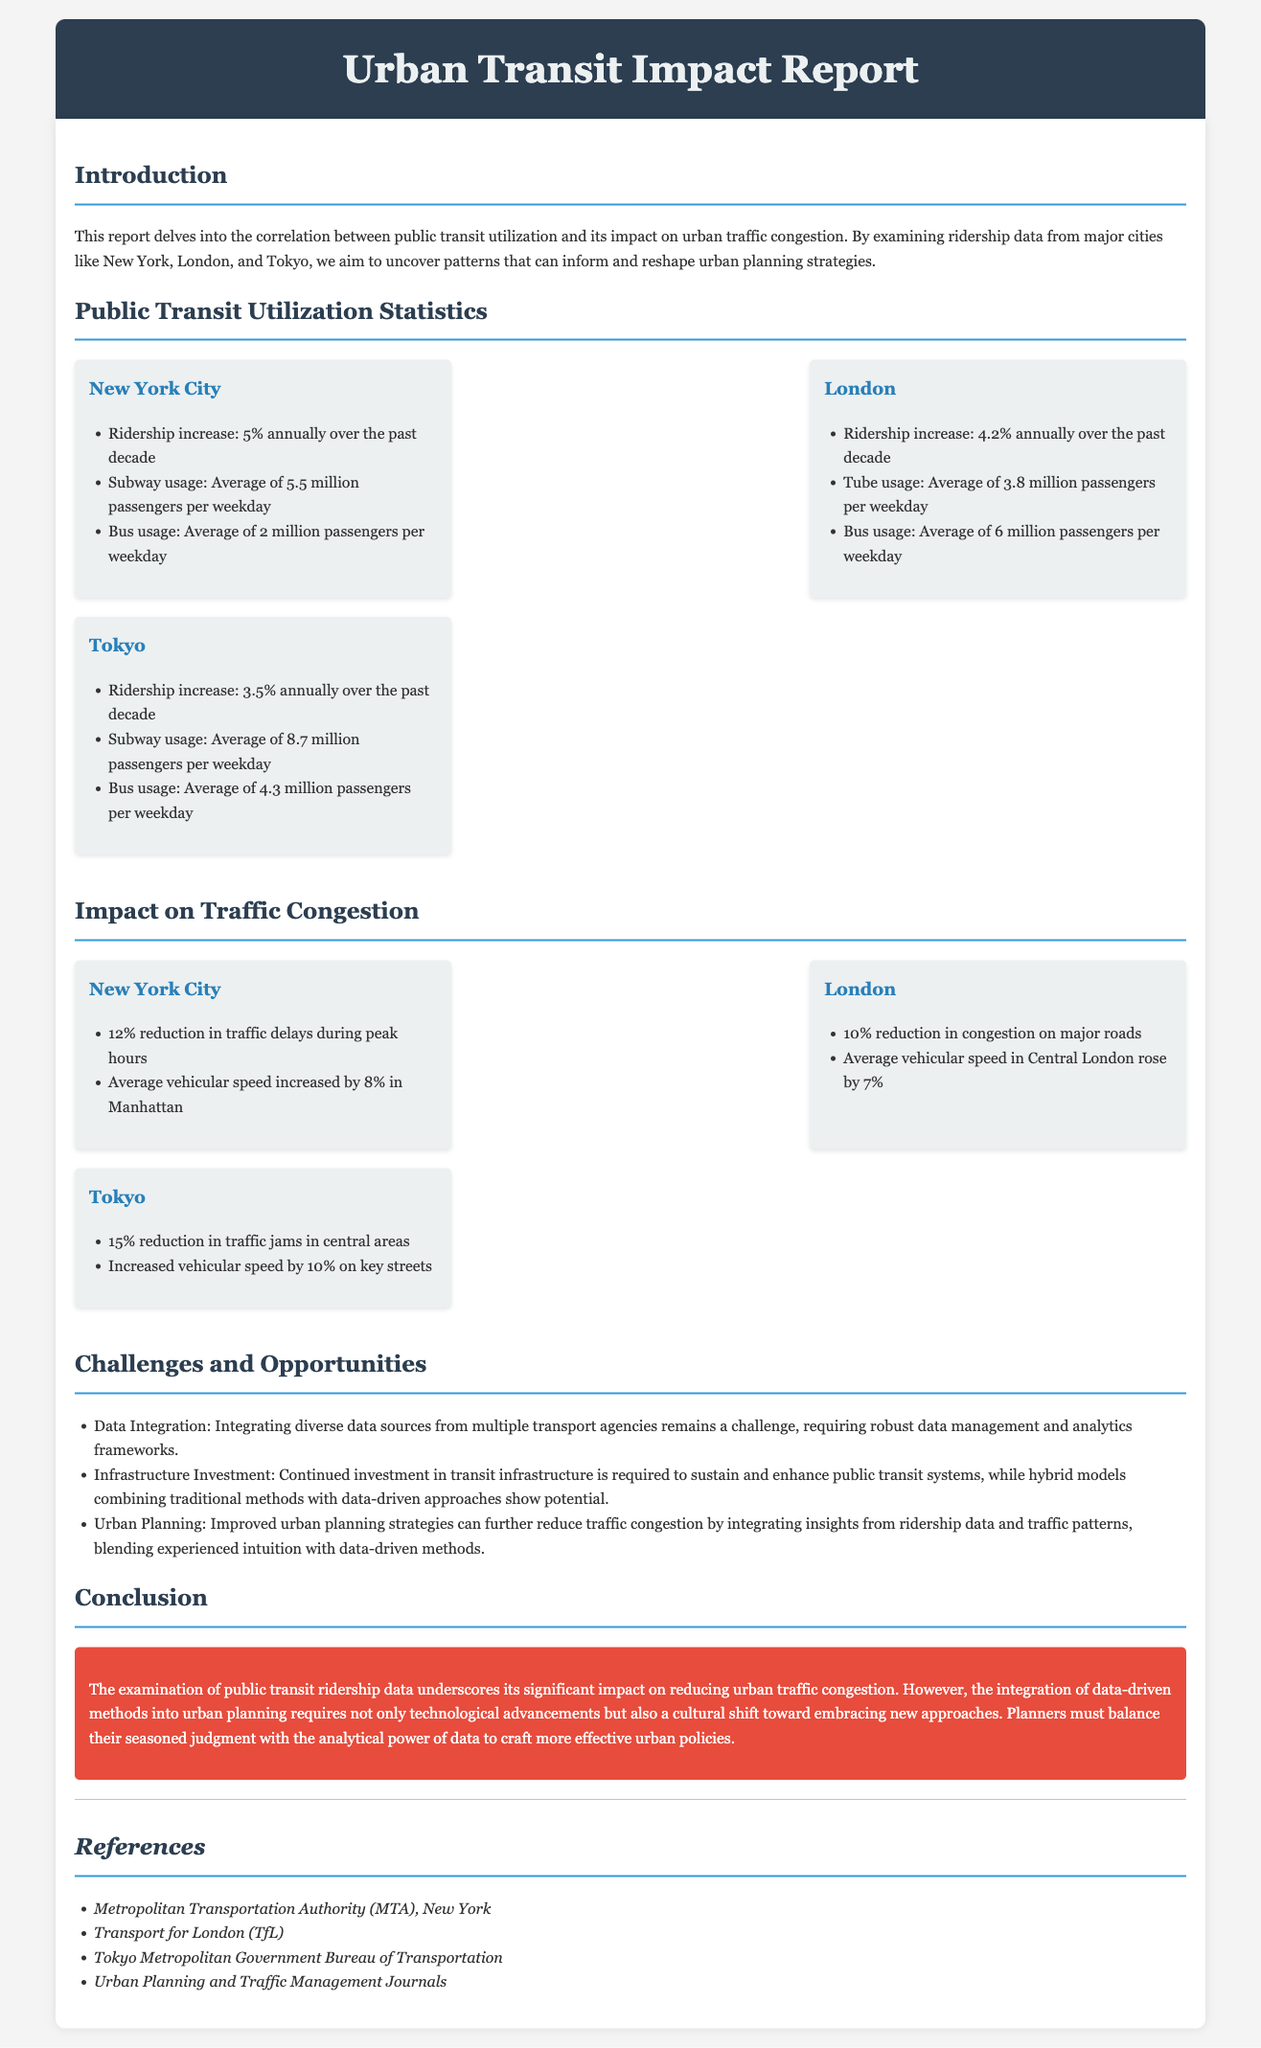what was the ridership increase in New York City? The report states that New York City experienced a ridership increase of 5% annually over the past decade.
Answer: 5% what is the average subway usage in Tokyo? The document indicates that Tokyo's average subway usage is 8.7 million passengers per weekday.
Answer: 8.7 million passengers how much did traffic delays reduce in London? According to the report, London experienced a 10% reduction in congestion on major roads.
Answer: 10% what is one challenge mentioned in the report? The report lists data integration as one of the challenges faced in the context of public transit and urban traffic.
Answer: Data Integration which city had the highest average bus usage? The report shows that London had the highest average bus usage with 6 million passengers per weekday.
Answer: London what is the vehicular speed increase in Manhattan? The examination reveals that the average vehicular speed in Manhattan increased by 8%.
Answer: 8% what is the conclusion regarding data-driven methods? The report concludes that a cultural shift towards embracing data-driven methods is necessary for urban planning.
Answer: Cultural shift 